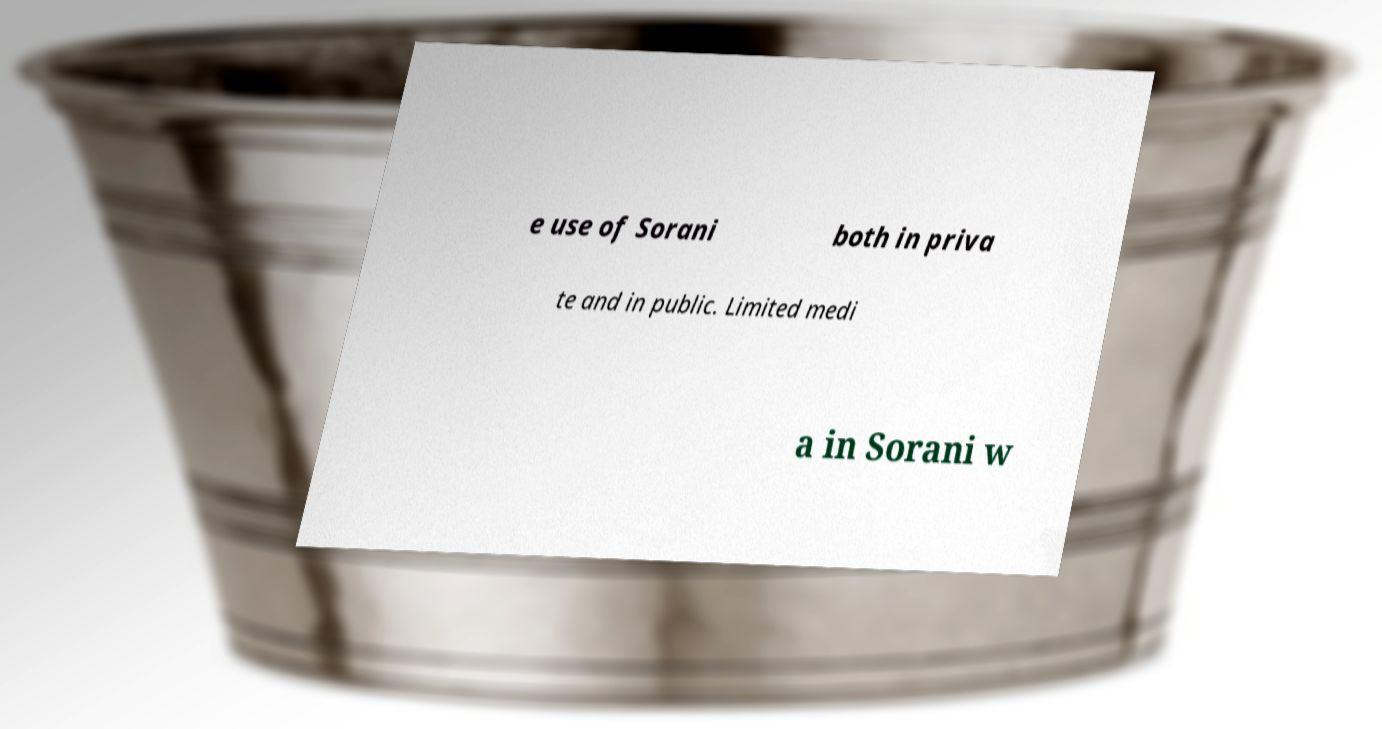For documentation purposes, I need the text within this image transcribed. Could you provide that? e use of Sorani both in priva te and in public. Limited medi a in Sorani w 